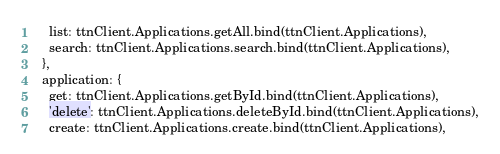<code> <loc_0><loc_0><loc_500><loc_500><_JavaScript_>    list: ttnClient.Applications.getAll.bind(ttnClient.Applications),
    search: ttnClient.Applications.search.bind(ttnClient.Applications),
  },
  application: {
    get: ttnClient.Applications.getById.bind(ttnClient.Applications),
    'delete': ttnClient.Applications.deleteById.bind(ttnClient.Applications),
    create: ttnClient.Applications.create.bind(ttnClient.Applications),</code> 